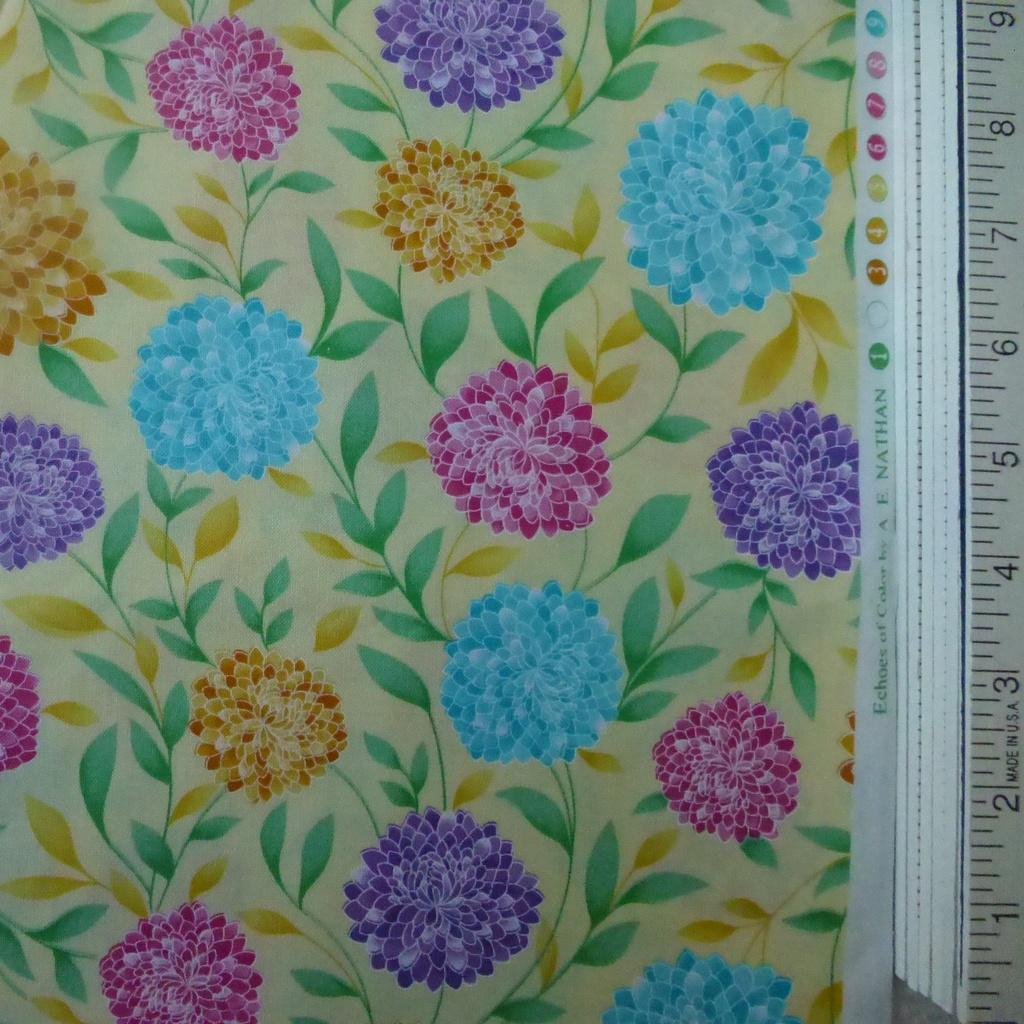What is the main object in the image that has a floral design? There is an object that resembles a cloth or a wall in the image, and it has a floral design. Where is the scale located in the image? The scale is on the right side of the image. Can you see the power of the ocean in the image? There is no ocean or any reference to power in the image; it features an object with a floral design and a scale. Is there a string attached to the floral design in the image? There is no string visible in the image; it only shows an object with a floral design and a scale. 